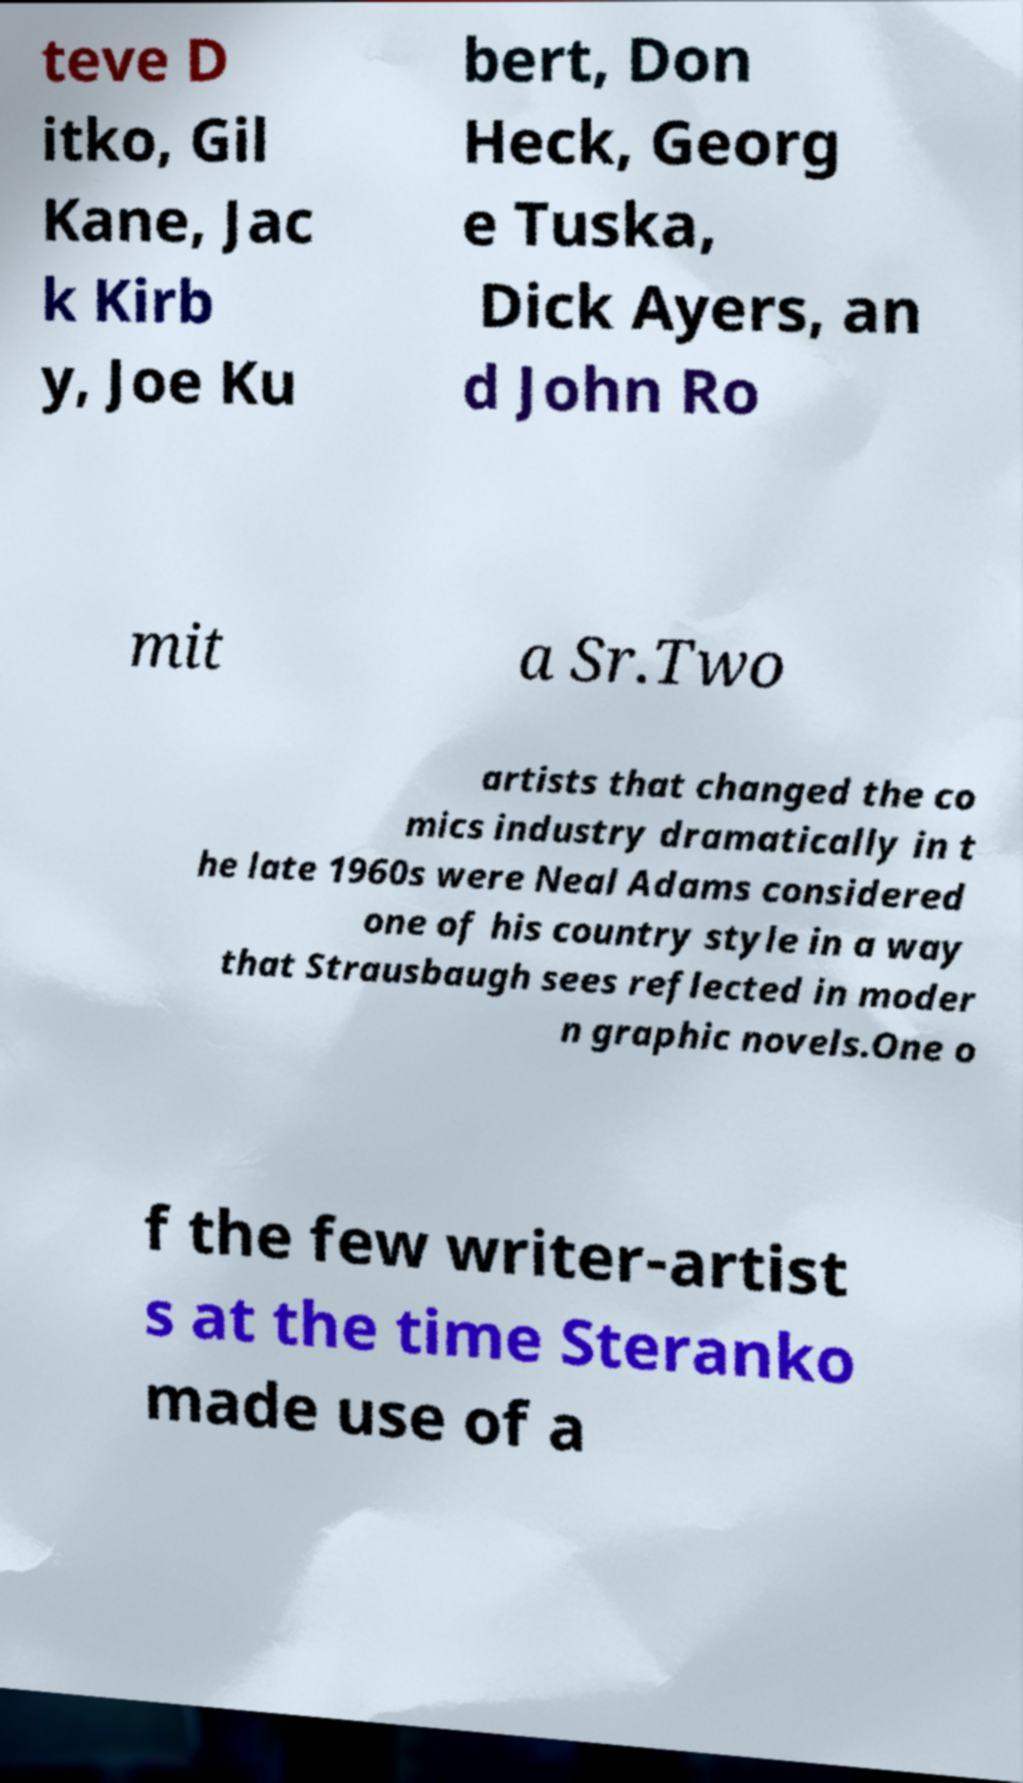Can you read and provide the text displayed in the image?This photo seems to have some interesting text. Can you extract and type it out for me? teve D itko, Gil Kane, Jac k Kirb y, Joe Ku bert, Don Heck, Georg e Tuska, Dick Ayers, an d John Ro mit a Sr.Two artists that changed the co mics industry dramatically in t he late 1960s were Neal Adams considered one of his country style in a way that Strausbaugh sees reflected in moder n graphic novels.One o f the few writer-artist s at the time Steranko made use of a 